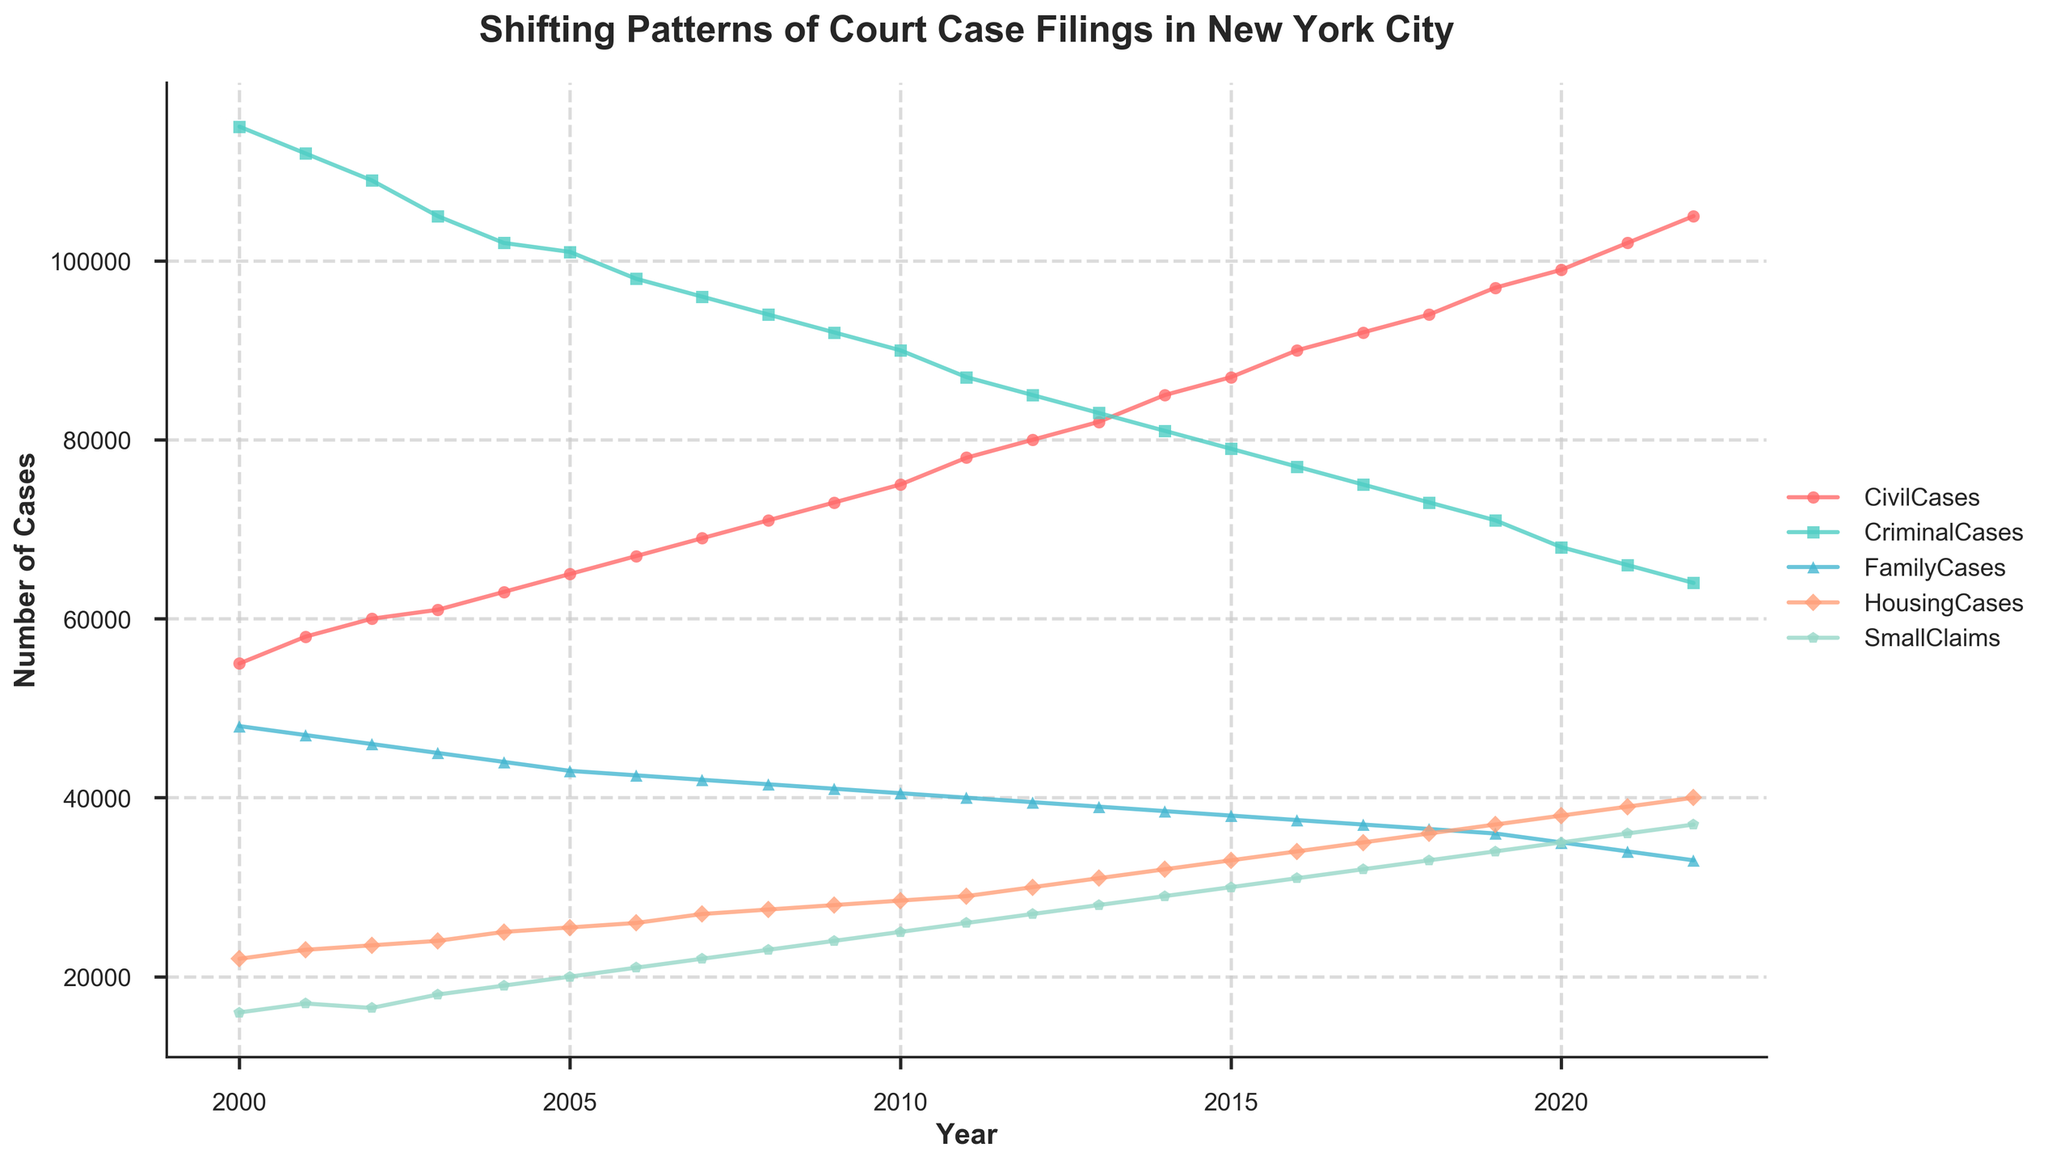What's the title of the figure? The title of the figure is displayed prominently at the top of the plot, which helps viewers understand the subject of the data being presented. From just looking at the figure, the title reads "Shifting Patterns of Court Case Filings in New York City."
Answer: Shifting Patterns of Court Case Filings in New York City Which year had the highest number of Civil Cases? To determine which year had the highest number of Civil Cases, we look at the line representing Civil Cases and identify the peak year. The figure shows that Civil Cases peaked in the year 2022.
Answer: 2022 How do the number of Family Cases change over time from 2000 to 2022? To answer this, we follow the trajectory of the line representing Family Cases from 2000 to 2022. The line shows a steady decrease in the number of Family Cases over these years.
Answer: Steady decrease Compare the number of Criminal Cases in 2000 and 2022. Which year had more cases and by how much? First, locate the points for Criminal Cases in 2000 and 2022 on the plot. In 2000, there were 115,000 cases, while in 2022, there were 64,000. Subtract 64,000 from 115,000 to find the difference of 51,000 cases.
Answer: 2000 had 51,000 more cases What is the general trend for Housing Cases from 2000 to 2022? By observing the line representing Housing Cases, it's clear that the number of cases has been increasing consistently over the years from 2000 to 2022.
Answer: Increasing What year did Small Claims Cases reach 30,000? Find the point where the Small Claims Cases line crosses the 30,000 mark on the y-axis. This occurs in the year 2015.
Answer: 2015 Which case type had the largest overall increase from 2000 to 2022? To determine the largest increase, we check the difference for each case type from 2000 to 2022. Civil Cases: 105,000 - 55,000 = 50,000, Criminal Cases: 64,000 - 115,000 = -51,000, Family Cases: 33,000 - 48,000 = -15,000, Housing Cases: 40,000 - 22,000 = 18,000, Small Claims: 37,000 - 16,000 = 21,000. Civil Cases had the largest increase of 50,000.
Answer: Civil Cases Which case type had a consistent declining trend throughout the years? By visually scanning the lines, we observe that Criminal Cases consistently decreased from 115,000 in 2000 to 64,000 in 2022.
Answer: Criminal Cases 